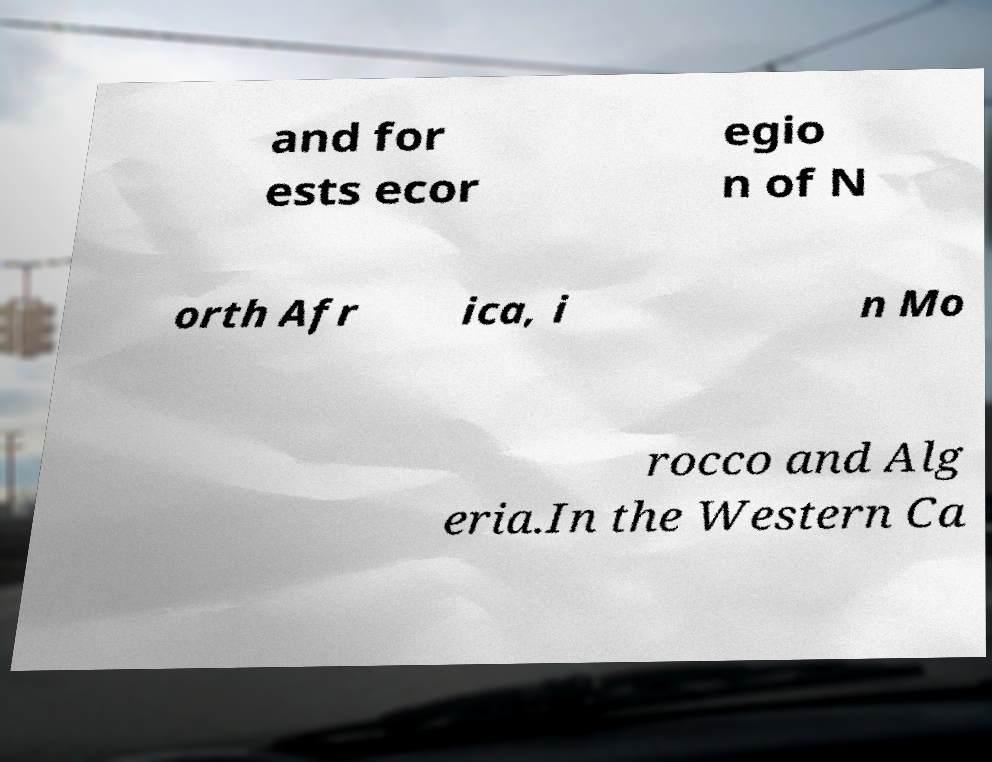I need the written content from this picture converted into text. Can you do that? and for ests ecor egio n of N orth Afr ica, i n Mo rocco and Alg eria.In the Western Ca 